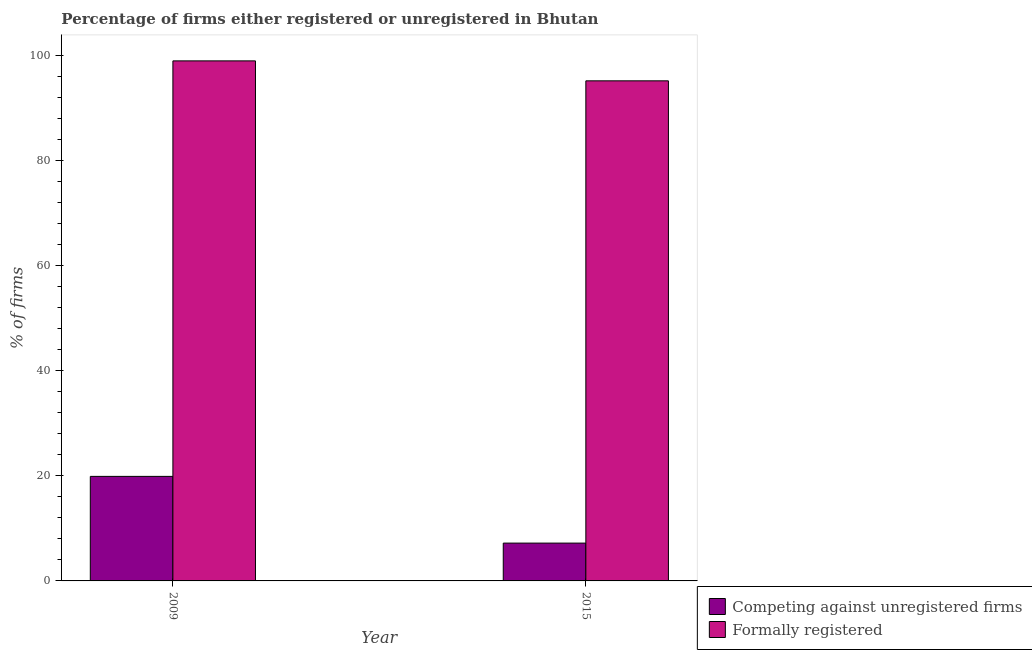How many different coloured bars are there?
Give a very brief answer. 2. How many groups of bars are there?
Make the answer very short. 2. Are the number of bars on each tick of the X-axis equal?
Your answer should be very brief. Yes. How many bars are there on the 2nd tick from the left?
Offer a very short reply. 2. In how many cases, is the number of bars for a given year not equal to the number of legend labels?
Provide a succinct answer. 0. Across all years, what is the maximum percentage of formally registered firms?
Provide a short and direct response. 99. Across all years, what is the minimum percentage of formally registered firms?
Ensure brevity in your answer.  95.2. In which year was the percentage of registered firms minimum?
Your answer should be very brief. 2015. What is the total percentage of registered firms in the graph?
Make the answer very short. 27.1. What is the difference between the percentage of formally registered firms in 2009 and that in 2015?
Make the answer very short. 3.8. What is the difference between the percentage of registered firms in 2009 and the percentage of formally registered firms in 2015?
Your answer should be very brief. 12.7. What is the average percentage of registered firms per year?
Offer a terse response. 13.55. In the year 2015, what is the difference between the percentage of registered firms and percentage of formally registered firms?
Provide a short and direct response. 0. What is the ratio of the percentage of formally registered firms in 2009 to that in 2015?
Your answer should be very brief. 1.04. Is the percentage of formally registered firms in 2009 less than that in 2015?
Provide a short and direct response. No. In how many years, is the percentage of formally registered firms greater than the average percentage of formally registered firms taken over all years?
Offer a very short reply. 1. What does the 2nd bar from the left in 2009 represents?
Make the answer very short. Formally registered. What does the 2nd bar from the right in 2015 represents?
Offer a terse response. Competing against unregistered firms. How many bars are there?
Your answer should be compact. 4. Are the values on the major ticks of Y-axis written in scientific E-notation?
Your answer should be compact. No. Does the graph contain grids?
Offer a very short reply. No. Where does the legend appear in the graph?
Offer a terse response. Bottom right. How are the legend labels stacked?
Your response must be concise. Vertical. What is the title of the graph?
Ensure brevity in your answer.  Percentage of firms either registered or unregistered in Bhutan. Does "Female entrants" appear as one of the legend labels in the graph?
Keep it short and to the point. No. What is the label or title of the X-axis?
Offer a very short reply. Year. What is the label or title of the Y-axis?
Your answer should be compact. % of firms. What is the % of firms in Formally registered in 2009?
Offer a terse response. 99. What is the % of firms in Competing against unregistered firms in 2015?
Offer a very short reply. 7.2. What is the % of firms in Formally registered in 2015?
Provide a succinct answer. 95.2. Across all years, what is the maximum % of firms of Competing against unregistered firms?
Your answer should be very brief. 19.9. Across all years, what is the minimum % of firms of Formally registered?
Make the answer very short. 95.2. What is the total % of firms in Competing against unregistered firms in the graph?
Offer a very short reply. 27.1. What is the total % of firms of Formally registered in the graph?
Provide a succinct answer. 194.2. What is the difference between the % of firms of Formally registered in 2009 and that in 2015?
Provide a short and direct response. 3.8. What is the difference between the % of firms in Competing against unregistered firms in 2009 and the % of firms in Formally registered in 2015?
Provide a succinct answer. -75.3. What is the average % of firms of Competing against unregistered firms per year?
Ensure brevity in your answer.  13.55. What is the average % of firms in Formally registered per year?
Your answer should be compact. 97.1. In the year 2009, what is the difference between the % of firms in Competing against unregistered firms and % of firms in Formally registered?
Offer a very short reply. -79.1. In the year 2015, what is the difference between the % of firms of Competing against unregistered firms and % of firms of Formally registered?
Your response must be concise. -88. What is the ratio of the % of firms in Competing against unregistered firms in 2009 to that in 2015?
Keep it short and to the point. 2.76. What is the ratio of the % of firms of Formally registered in 2009 to that in 2015?
Provide a short and direct response. 1.04. What is the difference between the highest and the lowest % of firms of Competing against unregistered firms?
Provide a succinct answer. 12.7. What is the difference between the highest and the lowest % of firms of Formally registered?
Provide a succinct answer. 3.8. 